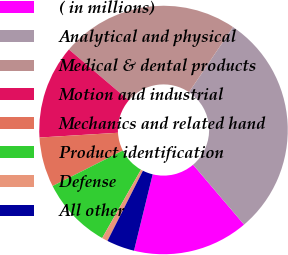Convert chart to OTSL. <chart><loc_0><loc_0><loc_500><loc_500><pie_chart><fcel>( in millions)<fcel>Analytical and physical<fcel>Medical & dental products<fcel>Motion and industrial<fcel>Mechanics and related hand<fcel>Product identification<fcel>Defense<fcel>All other<nl><fcel>15.05%<fcel>29.33%<fcel>23.22%<fcel>12.19%<fcel>6.48%<fcel>9.34%<fcel>0.77%<fcel>3.63%<nl></chart> 